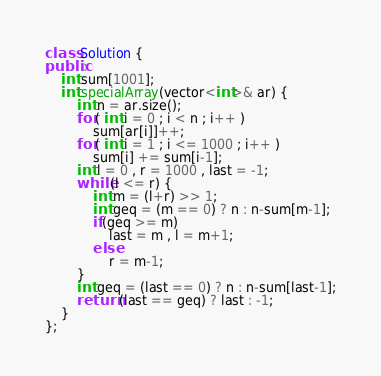<code> <loc_0><loc_0><loc_500><loc_500><_C++_>class Solution {
public:
    int sum[1001];
    int specialArray(vector<int>& ar) {
        int n = ar.size();
        for( int i = 0 ; i < n ; i++ )
            sum[ar[i]]++;
        for( int i = 1 ; i <= 1000 ; i++ )
            sum[i] += sum[i-1];
        int l = 0 , r = 1000 , last = -1;
        while(l <= r) {
            int m = (l+r) >> 1;
            int geq = (m == 0) ? n : n-sum[m-1];
            if(geq >= m)
                last = m , l = m+1;
            else
                r = m-1;
        }
        int geq = (last == 0) ? n : n-sum[last-1];
        return (last == geq) ? last : -1;
    }
};</code> 